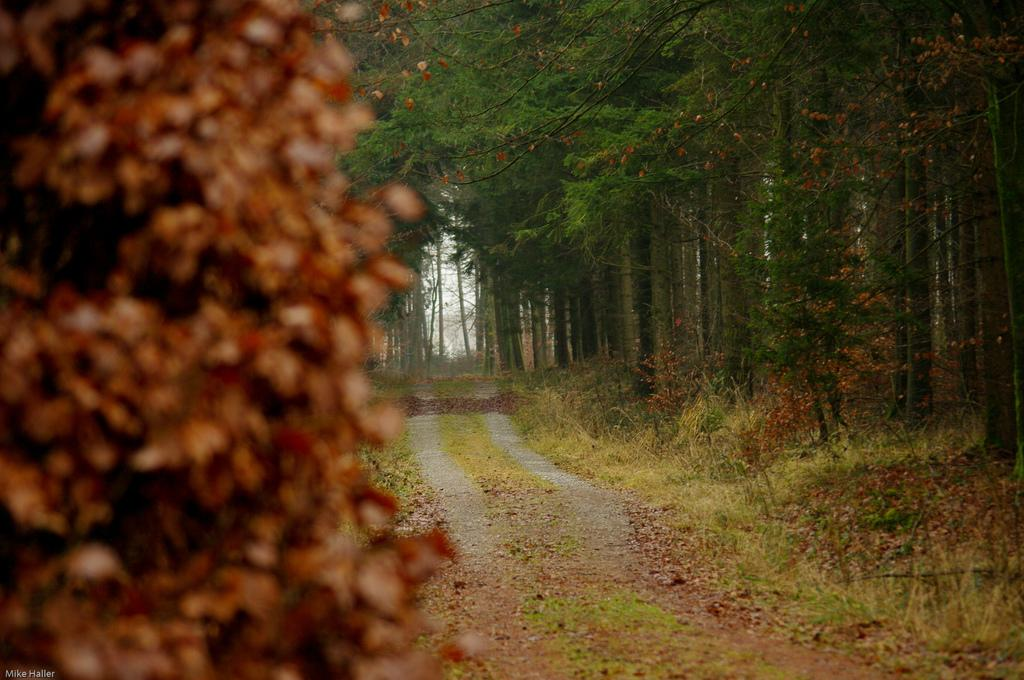What type of vegetation can be seen on both sides of the pavement in the image? There are trees on both sides of the pavement in the image. Can you describe the distribution of the trees in relation to the pavement? The trees are located on one side and the other side of the pavement. What type of ice can be seen melting on the pavement in the image? There is no ice present in the image; it only features trees on both sides of the pavement. 